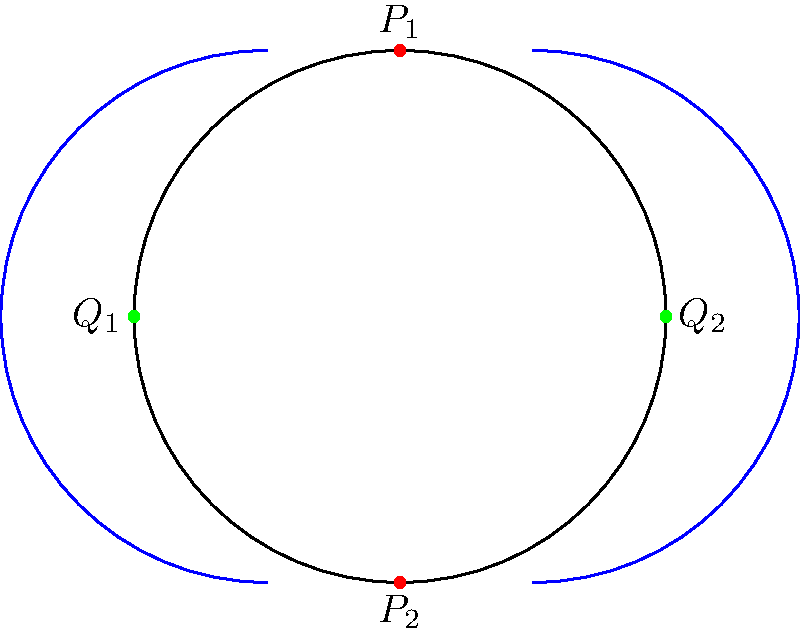In the Poincaré disk model of hyperbolic geometry shown above, two blue arcs represent parallel lines. Which of the following statements is true about these parallel lines?

A) They intersect at two points on the boundary of the disk
B) They have a common perpendicular line
C) They diverge in both directions
D) They converge in one direction and diverge in the other To understand the behavior of parallel lines in hyperbolic geometry, let's analyze the diagram step-by-step:

1) The circle represents the boundary of the Poincaré disk model, where all points inside the disk represent the hyperbolic plane.

2) The two blue arcs are representations of straight lines in hyperbolic geometry. They are parallel because they do not intersect within the disk.

3) In Euclidean geometry, parallel lines maintain a constant distance from each other. However, in hyperbolic geometry, this is not the case.

4) Notice that the blue arcs approach the boundary of the disk at four distinct points: $P_1$, $P_2$, $Q_1$, and $Q_2$.

5) The arcs get closer to each other near points $P_1$ and $P_2$ (top and bottom of the disk), but they get farther apart near points $Q_1$ and $Q_2$ (left and right of the disk).

6) This behavior indicates that these parallel lines diverge in both directions. As you move along either line towards the boundary of the disk, the distance between the lines increases.

7) It's important to note that while the lines appear to meet at the boundary of the disk, this boundary is not actually part of the hyperbolic plane. These points are called "ideal points" or points at infinity in hyperbolic geometry.

Therefore, the correct statement is that these parallel lines diverge in both directions.
Answer: C) They diverge in both directions 